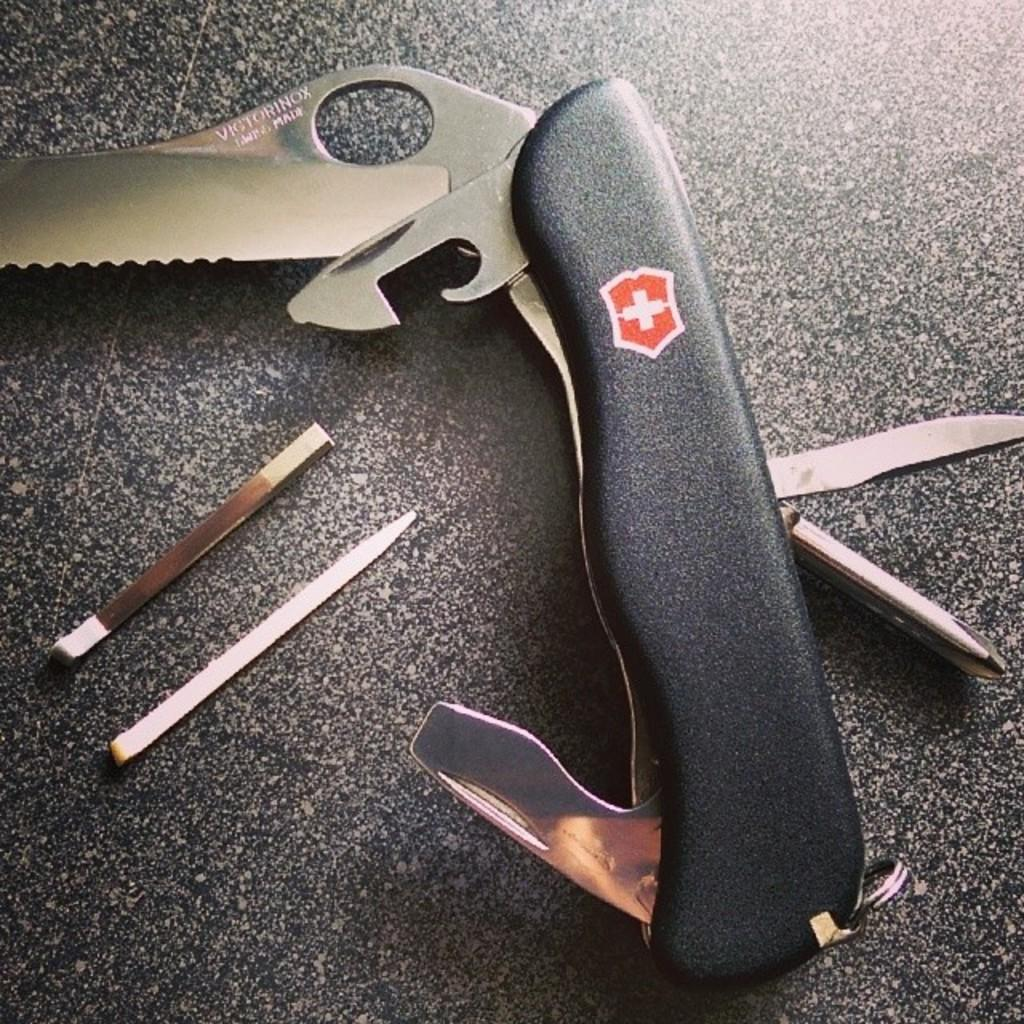What type of material is used for the objects in the image? The objects in the image are made of wood. Can you describe the knife-like object in the image? There is a knife-like object in the image, which may be used for cutting or carving. What is the color of the surface on which the objects are placed? The objects are on a black surface. What type of paste is being used to stick the wooden objects together in the image? There is no paste or indication of the wooden objects being stuck together in the image. 